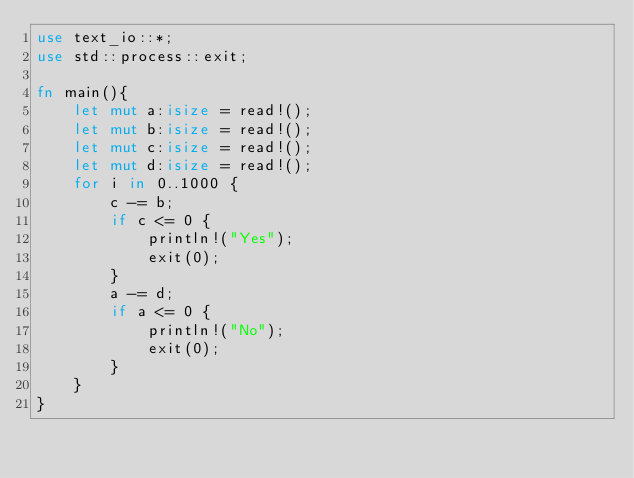<code> <loc_0><loc_0><loc_500><loc_500><_Rust_>use text_io::*;
use std::process::exit;

fn main(){
    let mut a:isize = read!();
    let mut b:isize = read!();
    let mut c:isize = read!();
    let mut d:isize = read!();
    for i in 0..1000 {
        c -= b;
        if c <= 0 {
            println!("Yes");
            exit(0);
        }
        a -= d;
        if a <= 0 {
            println!("No");
            exit(0);
        }
    }
}</code> 